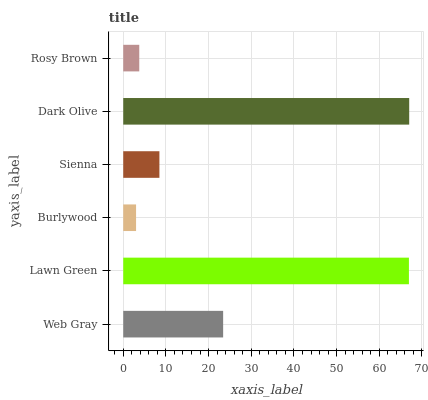Is Burlywood the minimum?
Answer yes or no. Yes. Is Dark Olive the maximum?
Answer yes or no. Yes. Is Lawn Green the minimum?
Answer yes or no. No. Is Lawn Green the maximum?
Answer yes or no. No. Is Lawn Green greater than Web Gray?
Answer yes or no. Yes. Is Web Gray less than Lawn Green?
Answer yes or no. Yes. Is Web Gray greater than Lawn Green?
Answer yes or no. No. Is Lawn Green less than Web Gray?
Answer yes or no. No. Is Web Gray the high median?
Answer yes or no. Yes. Is Sienna the low median?
Answer yes or no. Yes. Is Burlywood the high median?
Answer yes or no. No. Is Lawn Green the low median?
Answer yes or no. No. 